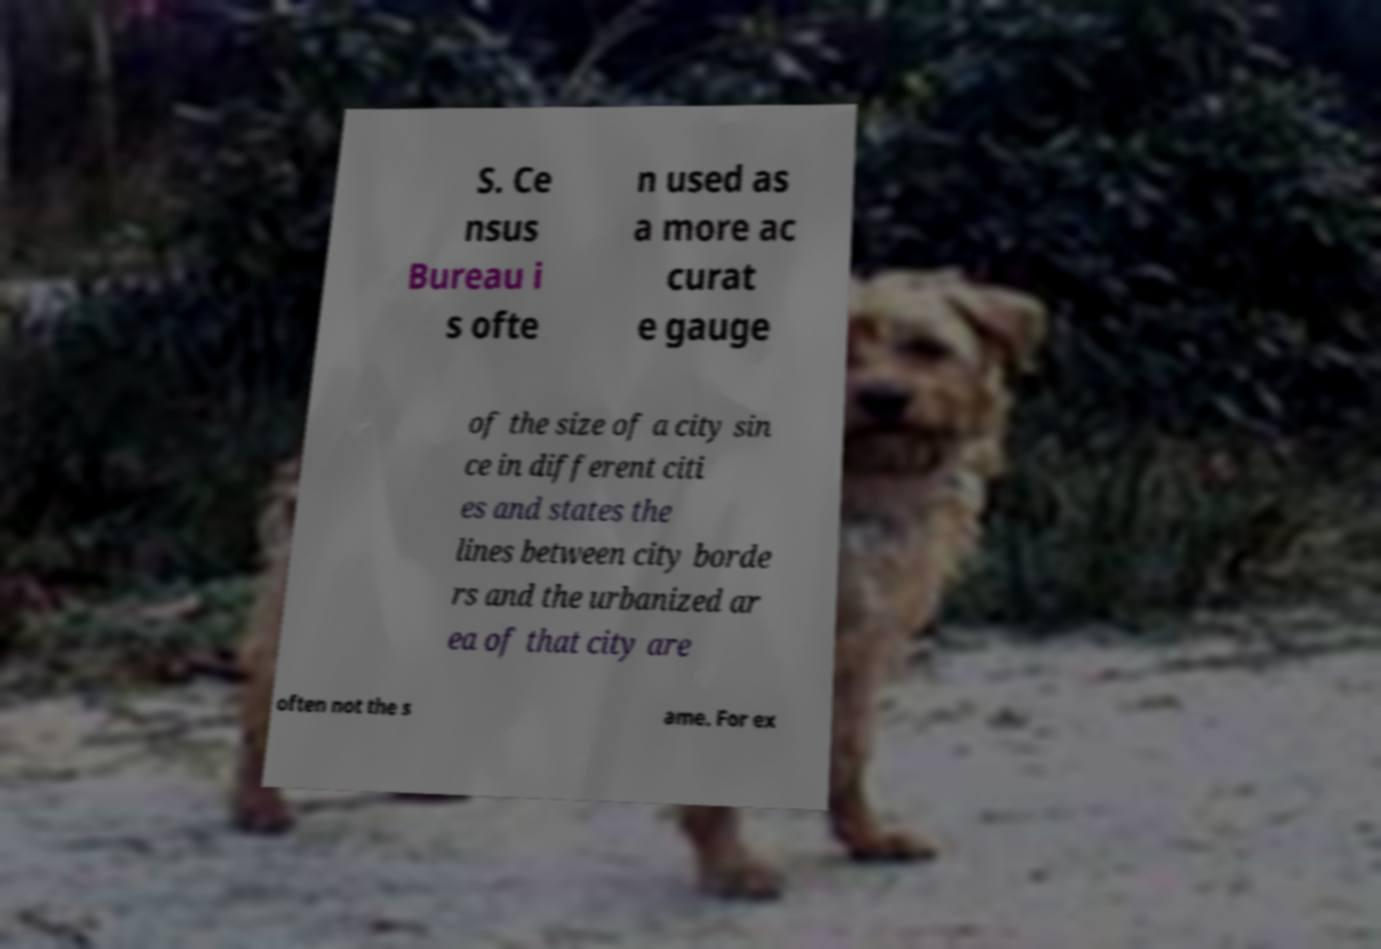I need the written content from this picture converted into text. Can you do that? S. Ce nsus Bureau i s ofte n used as a more ac curat e gauge of the size of a city sin ce in different citi es and states the lines between city borde rs and the urbanized ar ea of that city are often not the s ame. For ex 